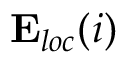<formula> <loc_0><loc_0><loc_500><loc_500>\mathbf E _ { l o c } ( \ r _ { i } )</formula> 